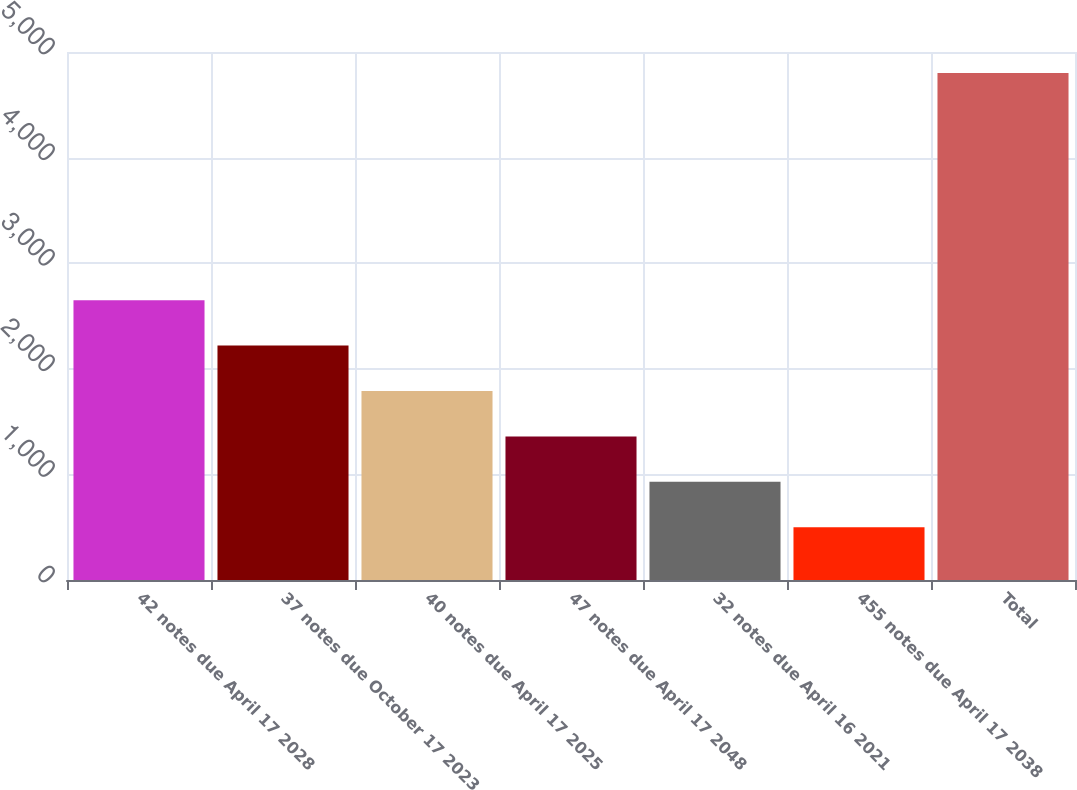Convert chart to OTSL. <chart><loc_0><loc_0><loc_500><loc_500><bar_chart><fcel>42 notes due April 17 2028<fcel>37 notes due October 17 2023<fcel>40 notes due April 17 2025<fcel>47 notes due April 17 2048<fcel>32 notes due April 16 2021<fcel>455 notes due April 17 2038<fcel>Total<nl><fcel>2650<fcel>2220<fcel>1790<fcel>1360<fcel>930<fcel>500<fcel>4800<nl></chart> 